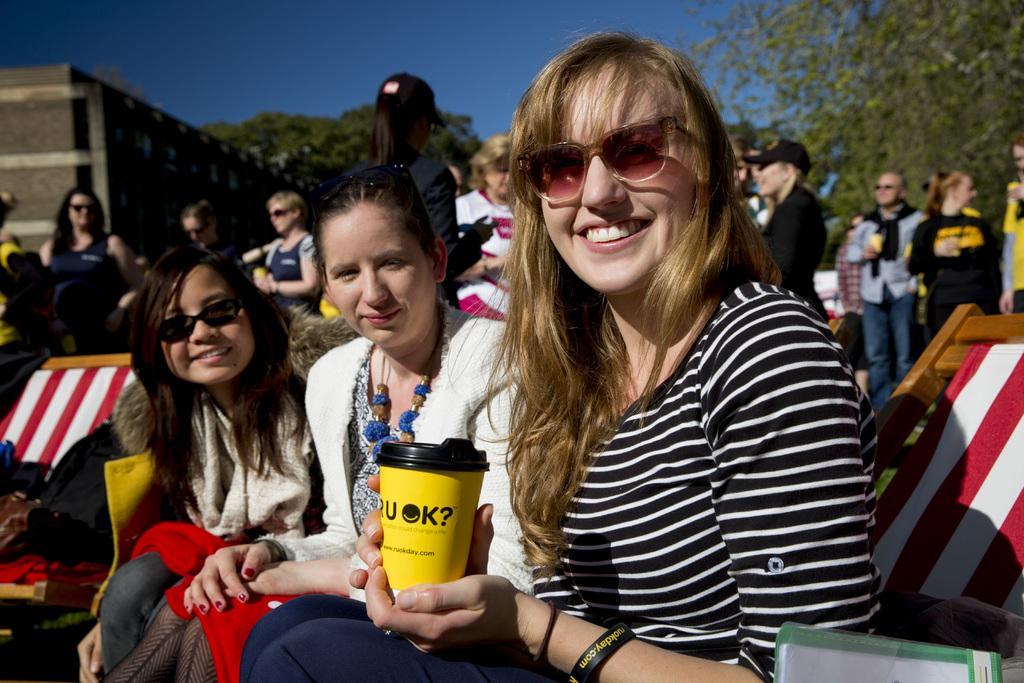Can you describe this image briefly? In this image we can see a three people sitting. In that a woman is holding a glass with a lid. On the backside we can see a group of people, a building with windows, trees and the sky. 